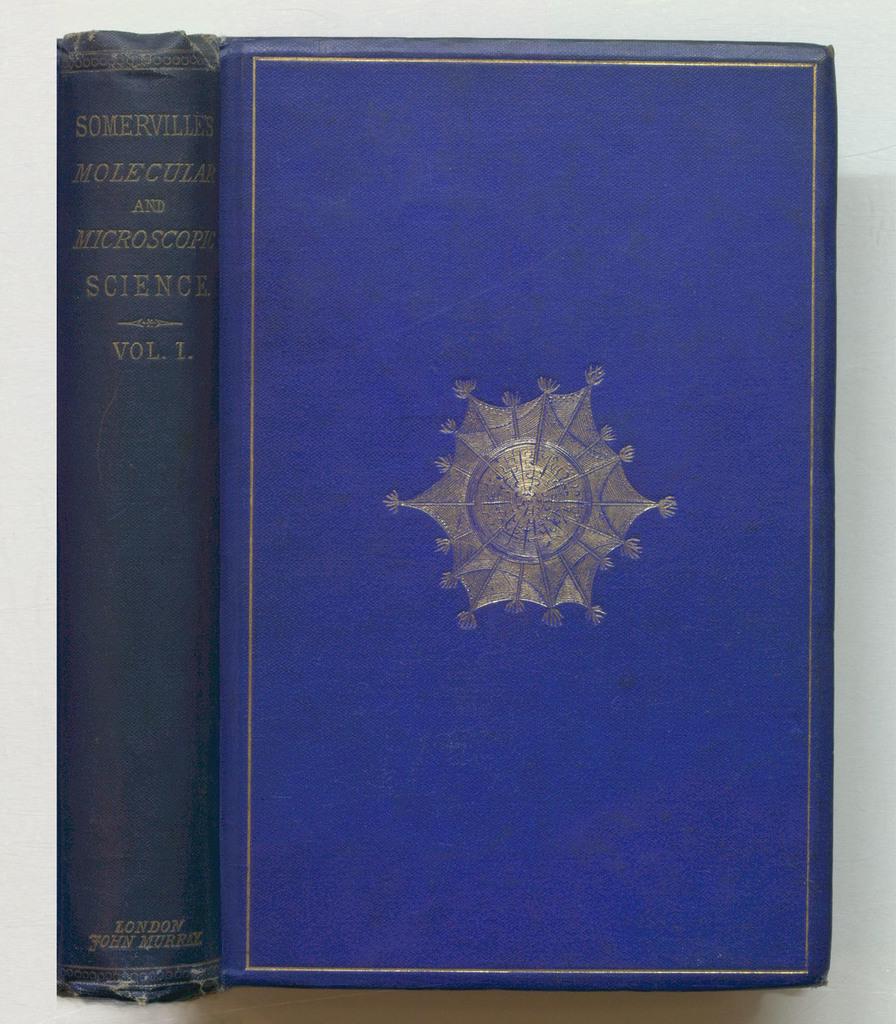Who wrote this book?
Provide a succinct answer. John murray. 